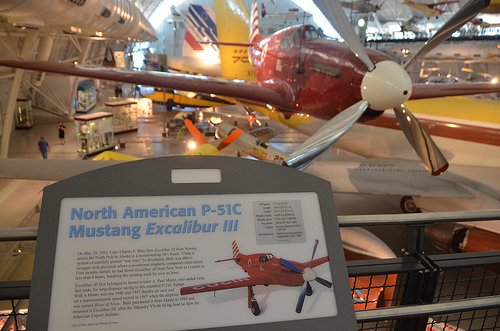<image>
Is the propeller on the plane? Yes. Looking at the image, I can see the propeller is positioned on top of the plane, with the plane providing support. 